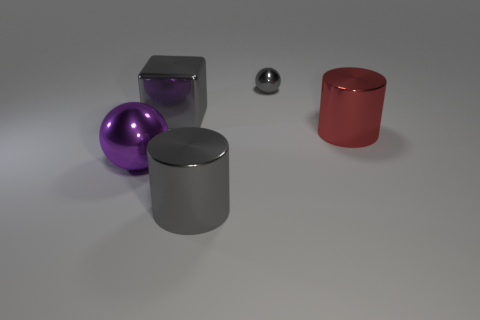What material is the red object?
Your answer should be compact. Metal. What number of big things are shiny balls or red things?
Keep it short and to the point. 2. There is a big purple ball; what number of large gray objects are on the left side of it?
Provide a short and direct response. 0. Is there a big object of the same color as the big sphere?
Your answer should be compact. No. The red thing that is the same size as the gray block is what shape?
Your response must be concise. Cylinder. What number of red objects are tiny metallic cubes or big metal things?
Provide a short and direct response. 1. How many gray metallic blocks have the same size as the red metallic cylinder?
Keep it short and to the point. 1. What shape is the large object that is the same color as the shiny cube?
Provide a short and direct response. Cylinder. What number of things are either green metallic cylinders or big cylinders right of the gray metallic cube?
Keep it short and to the point. 2. Do the red shiny object in front of the tiny metal object and the shiny cylinder in front of the large red object have the same size?
Give a very brief answer. Yes. 